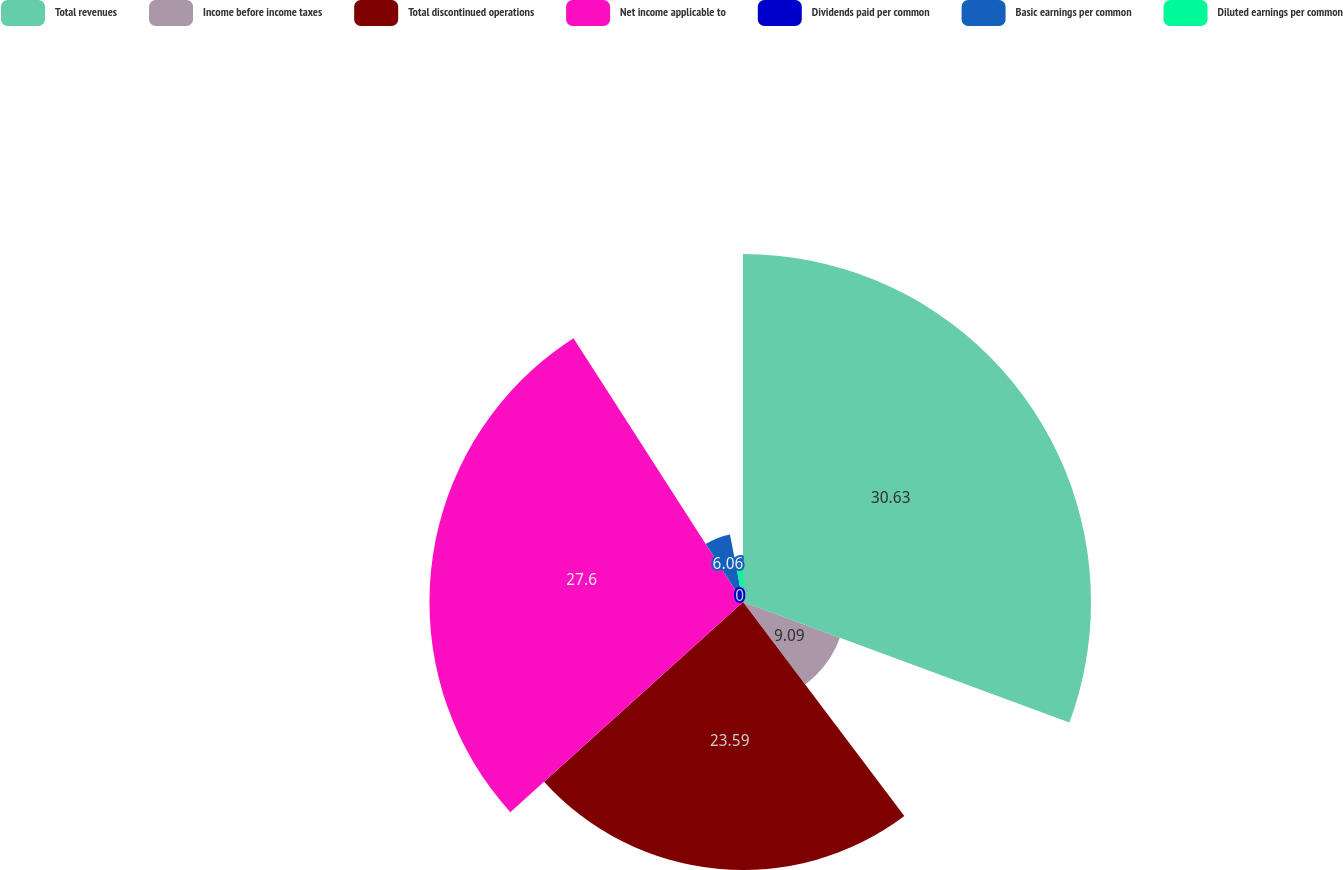Convert chart to OTSL. <chart><loc_0><loc_0><loc_500><loc_500><pie_chart><fcel>Total revenues<fcel>Income before income taxes<fcel>Total discontinued operations<fcel>Net income applicable to<fcel>Dividends paid per common<fcel>Basic earnings per common<fcel>Diluted earnings per common<nl><fcel>30.63%<fcel>9.09%<fcel>23.59%<fcel>27.6%<fcel>0.0%<fcel>6.06%<fcel>3.03%<nl></chart> 